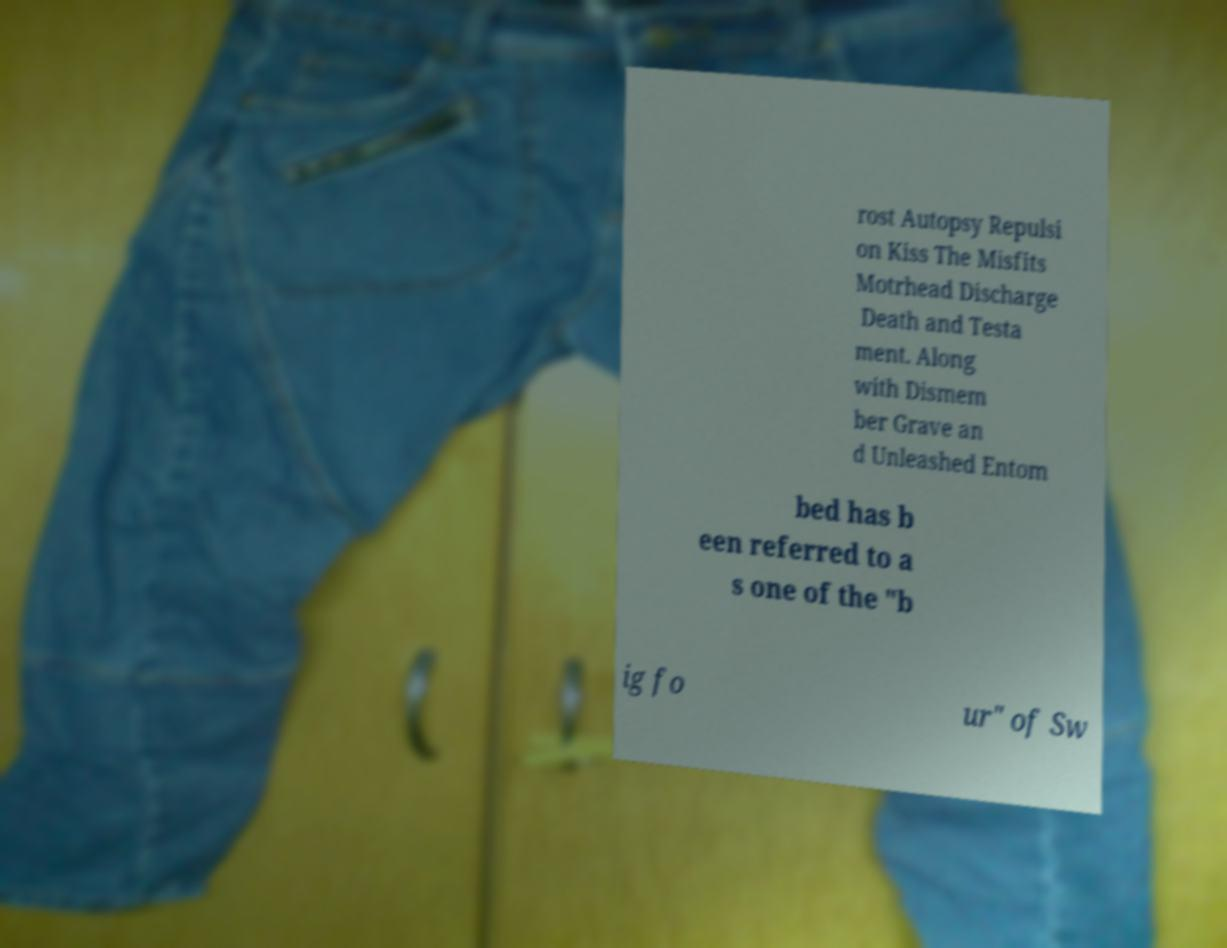I need the written content from this picture converted into text. Can you do that? rost Autopsy Repulsi on Kiss The Misfits Motrhead Discharge Death and Testa ment. Along with Dismem ber Grave an d Unleashed Entom bed has b een referred to a s one of the "b ig fo ur" of Sw 